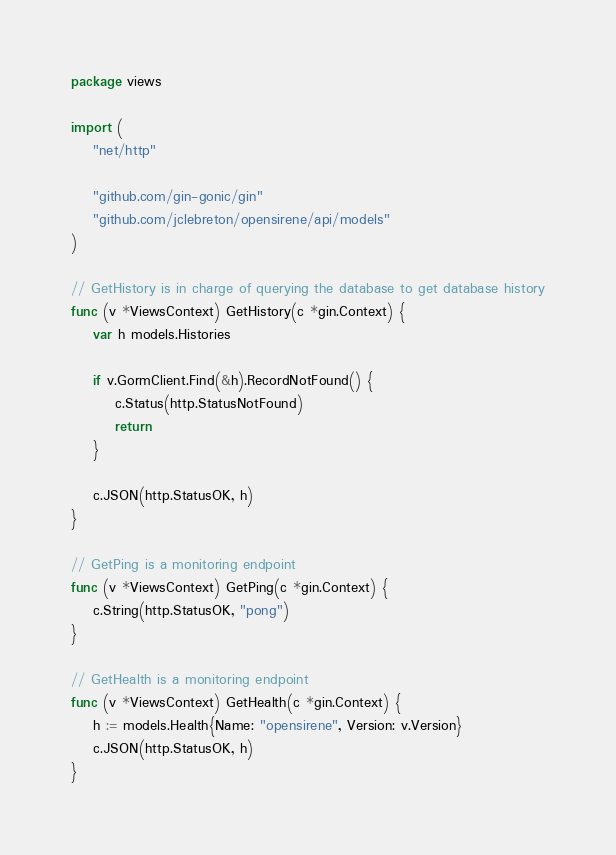Convert code to text. <code><loc_0><loc_0><loc_500><loc_500><_Go_>package views

import (
	"net/http"

	"github.com/gin-gonic/gin"
	"github.com/jclebreton/opensirene/api/models"
)

// GetHistory is in charge of querying the database to get database history
func (v *ViewsContext) GetHistory(c *gin.Context) {
	var h models.Histories

	if v.GormClient.Find(&h).RecordNotFound() {
		c.Status(http.StatusNotFound)
		return
	}

	c.JSON(http.StatusOK, h)
}

// GetPing is a monitoring endpoint
func (v *ViewsContext) GetPing(c *gin.Context) {
	c.String(http.StatusOK, "pong")
}

// GetHealth is a monitoring endpoint
func (v *ViewsContext) GetHealth(c *gin.Context) {
	h := models.Health{Name: "opensirene", Version: v.Version}
	c.JSON(http.StatusOK, h)
}
</code> 